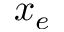Convert formula to latex. <formula><loc_0><loc_0><loc_500><loc_500>x _ { e }</formula> 